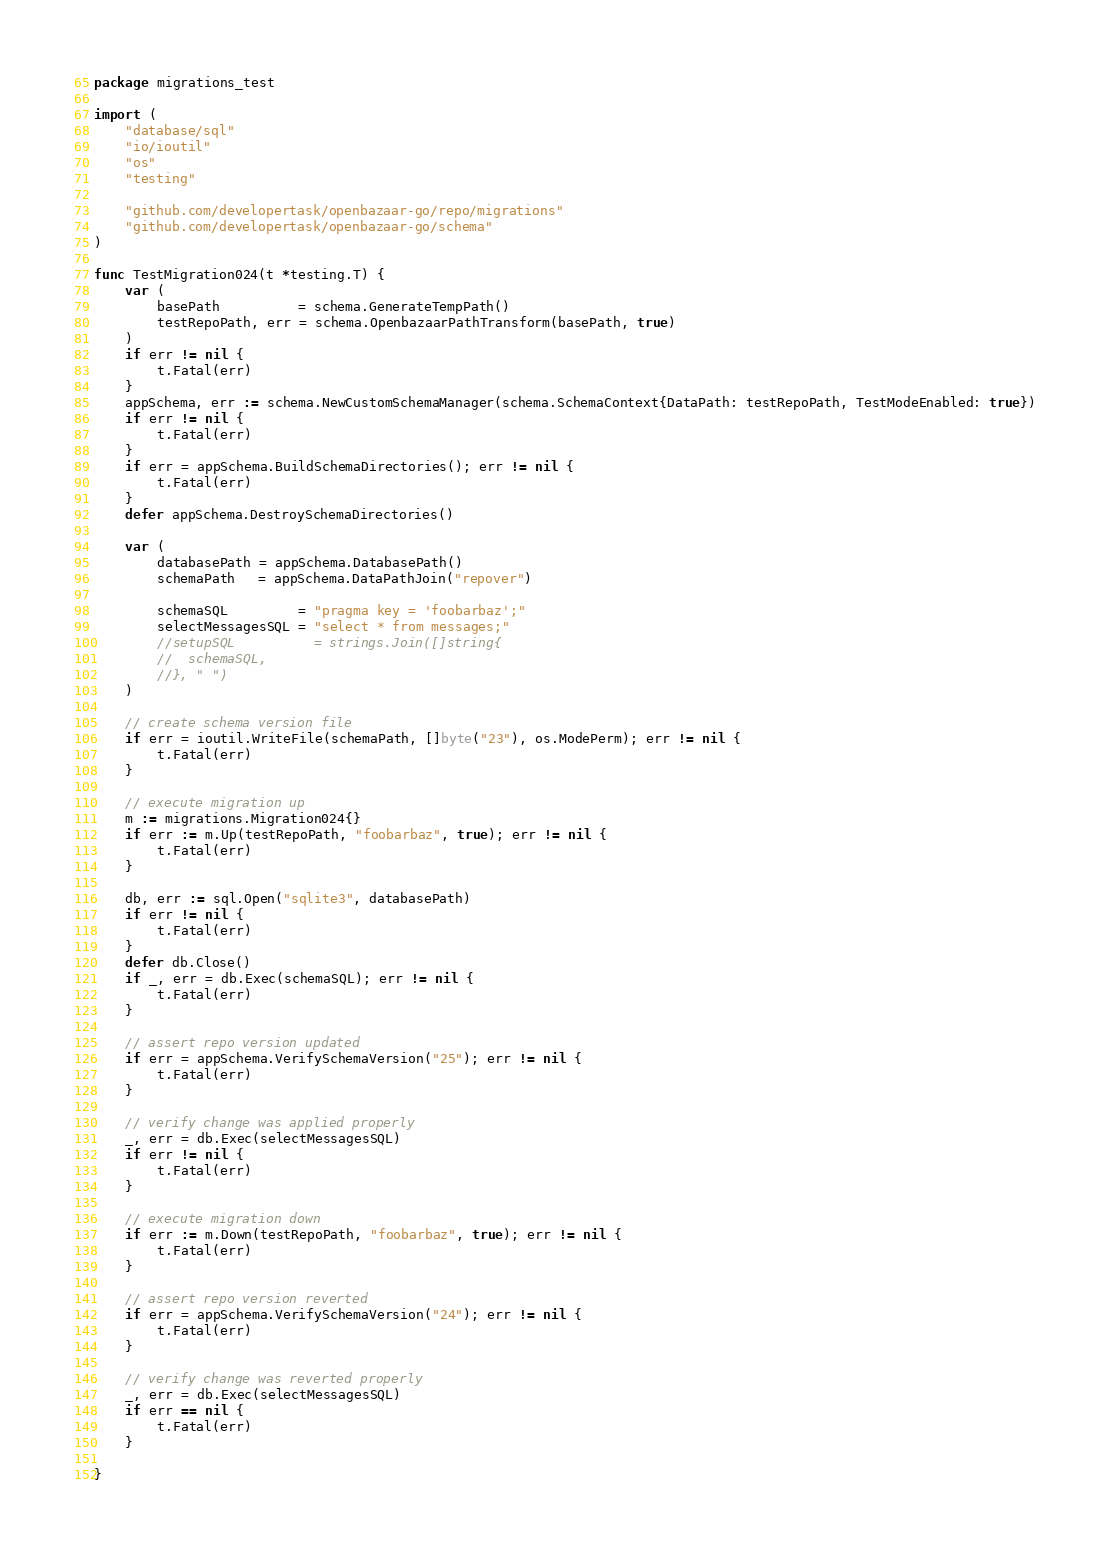<code> <loc_0><loc_0><loc_500><loc_500><_Go_>package migrations_test

import (
	"database/sql"
	"io/ioutil"
	"os"
	"testing"

	"github.com/developertask/openbazaar-go/repo/migrations"
	"github.com/developertask/openbazaar-go/schema"
)

func TestMigration024(t *testing.T) {
	var (
		basePath          = schema.GenerateTempPath()
		testRepoPath, err = schema.OpenbazaarPathTransform(basePath, true)
	)
	if err != nil {
		t.Fatal(err)
	}
	appSchema, err := schema.NewCustomSchemaManager(schema.SchemaContext{DataPath: testRepoPath, TestModeEnabled: true})
	if err != nil {
		t.Fatal(err)
	}
	if err = appSchema.BuildSchemaDirectories(); err != nil {
		t.Fatal(err)
	}
	defer appSchema.DestroySchemaDirectories()

	var (
		databasePath = appSchema.DatabasePath()
		schemaPath   = appSchema.DataPathJoin("repover")

		schemaSQL         = "pragma key = 'foobarbaz';"
		selectMessagesSQL = "select * from messages;"
		//setupSQL          = strings.Join([]string{
		//	schemaSQL,
		//}, " ")
	)

	// create schema version file
	if err = ioutil.WriteFile(schemaPath, []byte("23"), os.ModePerm); err != nil {
		t.Fatal(err)
	}

	// execute migration up
	m := migrations.Migration024{}
	if err := m.Up(testRepoPath, "foobarbaz", true); err != nil {
		t.Fatal(err)
	}

	db, err := sql.Open("sqlite3", databasePath)
	if err != nil {
		t.Fatal(err)
	}
	defer db.Close()
	if _, err = db.Exec(schemaSQL); err != nil {
		t.Fatal(err)
	}

	// assert repo version updated
	if err = appSchema.VerifySchemaVersion("25"); err != nil {
		t.Fatal(err)
	}

	// verify change was applied properly
	_, err = db.Exec(selectMessagesSQL)
	if err != nil {
		t.Fatal(err)
	}

	// execute migration down
	if err := m.Down(testRepoPath, "foobarbaz", true); err != nil {
		t.Fatal(err)
	}

	// assert repo version reverted
	if err = appSchema.VerifySchemaVersion("24"); err != nil {
		t.Fatal(err)
	}

	// verify change was reverted properly
	_, err = db.Exec(selectMessagesSQL)
	if err == nil {
		t.Fatal(err)
	}

}
</code> 